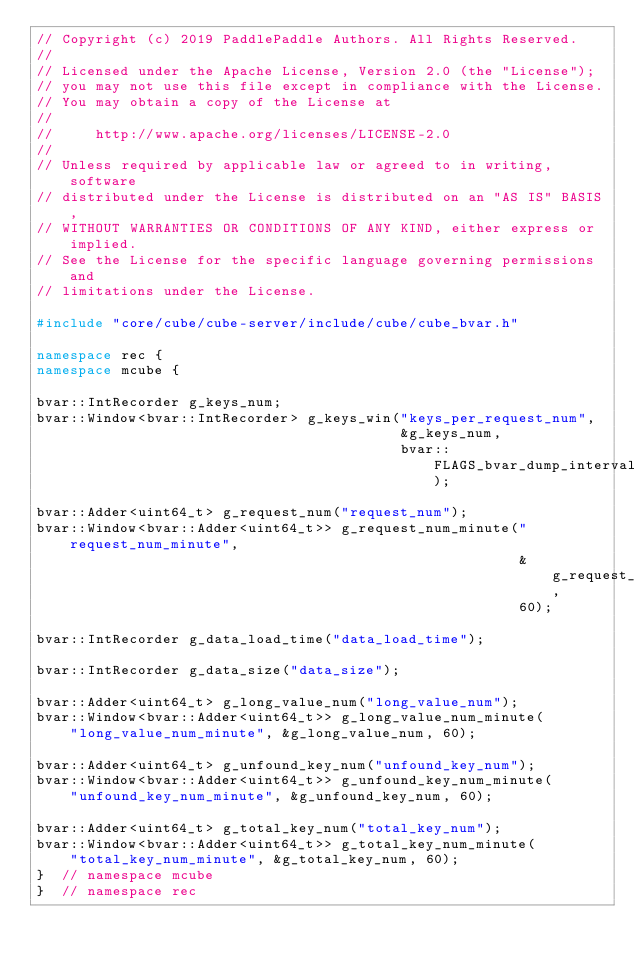Convert code to text. <code><loc_0><loc_0><loc_500><loc_500><_C++_>// Copyright (c) 2019 PaddlePaddle Authors. All Rights Reserved.
//
// Licensed under the Apache License, Version 2.0 (the "License");
// you may not use this file except in compliance with the License.
// You may obtain a copy of the License at
//
//     http://www.apache.org/licenses/LICENSE-2.0
//
// Unless required by applicable law or agreed to in writing, software
// distributed under the License is distributed on an "AS IS" BASIS,
// WITHOUT WARRANTIES OR CONDITIONS OF ANY KIND, either express or implied.
// See the License for the specific language governing permissions and
// limitations under the License.

#include "core/cube/cube-server/include/cube/cube_bvar.h"

namespace rec {
namespace mcube {

bvar::IntRecorder g_keys_num;
bvar::Window<bvar::IntRecorder> g_keys_win("keys_per_request_num",
                                           &g_keys_num,
                                           bvar::FLAGS_bvar_dump_interval);

bvar::Adder<uint64_t> g_request_num("request_num");
bvar::Window<bvar::Adder<uint64_t>> g_request_num_minute("request_num_minute",
                                                         &g_request_num,
                                                         60);

bvar::IntRecorder g_data_load_time("data_load_time");

bvar::IntRecorder g_data_size("data_size");

bvar::Adder<uint64_t> g_long_value_num("long_value_num");
bvar::Window<bvar::Adder<uint64_t>> g_long_value_num_minute(
    "long_value_num_minute", &g_long_value_num, 60);

bvar::Adder<uint64_t> g_unfound_key_num("unfound_key_num");
bvar::Window<bvar::Adder<uint64_t>> g_unfound_key_num_minute(
    "unfound_key_num_minute", &g_unfound_key_num, 60);

bvar::Adder<uint64_t> g_total_key_num("total_key_num");
bvar::Window<bvar::Adder<uint64_t>> g_total_key_num_minute(
    "total_key_num_minute", &g_total_key_num, 60);
}  // namespace mcube
}  // namespace rec
</code> 